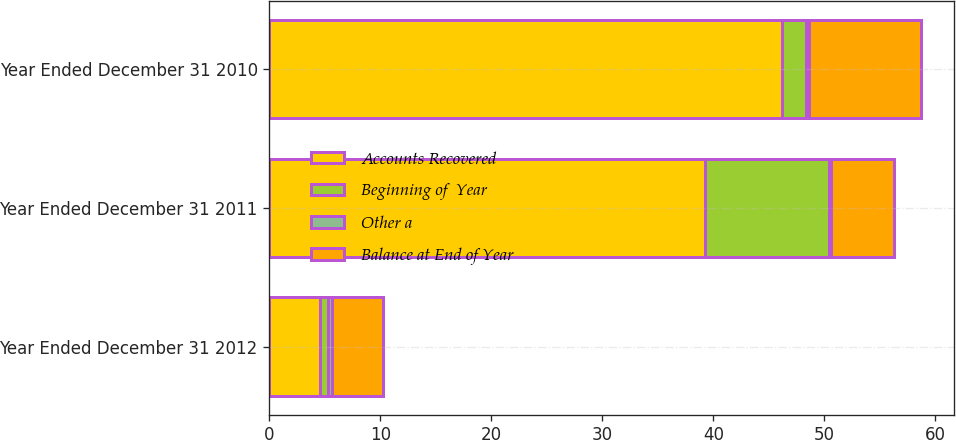Convert chart to OTSL. <chart><loc_0><loc_0><loc_500><loc_500><stacked_bar_chart><ecel><fcel>Year Ended December 31 2012<fcel>Year Ended December 31 2011<fcel>Year Ended December 31 2010<nl><fcel>Accounts Recovered<fcel>4.6<fcel>39.2<fcel>46.2<nl><fcel>Beginning of  Year<fcel>0.7<fcel>11.2<fcel>2.1<nl><fcel>Other a<fcel>0.3<fcel>0.2<fcel>0.3<nl><fcel>Balance at End of Year<fcel>4.6<fcel>5.7<fcel>10.1<nl></chart> 